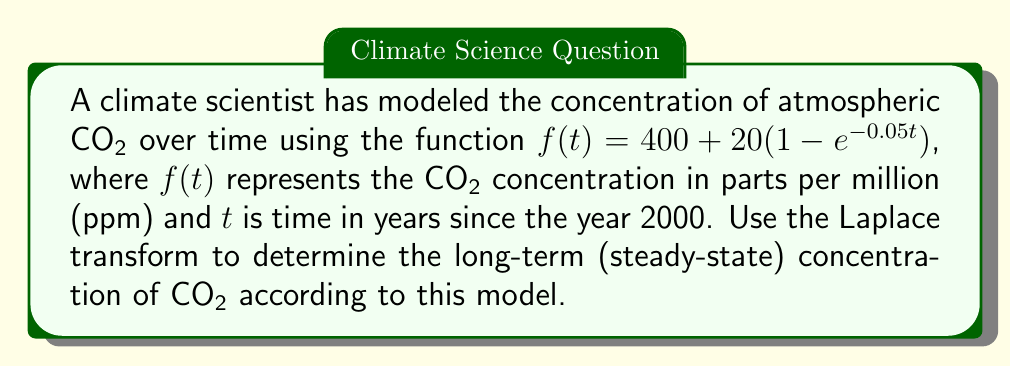Teach me how to tackle this problem. To solve this problem using the Laplace transform, we'll follow these steps:

1) First, recall the final value theorem for Laplace transforms:
   
   $$\lim_{t \to \infty} f(t) = \lim_{s \to 0} sF(s)$$

   where $F(s)$ is the Laplace transform of $f(t)$.

2) We need to find the Laplace transform of $f(t)$. Let's break it down:

   $f(t) = 400 + 20(1 - e^{-0.05t})$
   $f(t) = 400 + 20 - 20e^{-0.05t}$
   $f(t) = 420 - 20e^{-0.05t}$

3) Now, let's take the Laplace transform of each term:

   $\mathcal{L}\{420\} = \frac{420}{s}$
   $\mathcal{L}\{-20e^{-0.05t}\} = -\frac{20}{s+0.05}$

4) Therefore, the Laplace transform of $f(t)$ is:

   $$F(s) = \frac{420}{s} - \frac{20}{s+0.05}$$

5) According to the final value theorem, we need to calculate:

   $$\lim_{s \to 0} s(\frac{420}{s} - \frac{20}{s+0.05})$$

6) Let's evaluate this limit:

   $$\lim_{s \to 0} (420 - \frac{20s}{s+0.05})$$
   
   $$= 420 - \lim_{s \to 0} \frac{20s}{s+0.05}$$
   
   $$= 420 - 0 = 420$$

Therefore, the long-term (steady-state) concentration of CO₂ according to this model is 420 ppm.
Answer: 420 ppm 